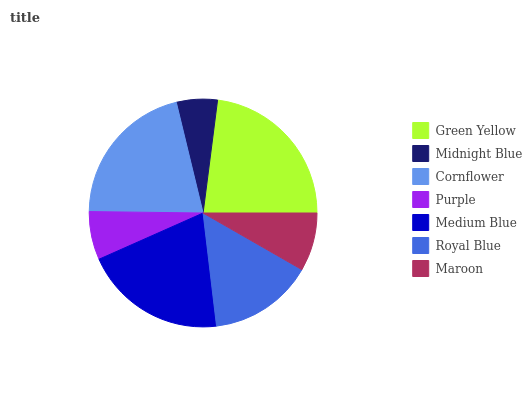Is Midnight Blue the minimum?
Answer yes or no. Yes. Is Green Yellow the maximum?
Answer yes or no. Yes. Is Cornflower the minimum?
Answer yes or no. No. Is Cornflower the maximum?
Answer yes or no. No. Is Cornflower greater than Midnight Blue?
Answer yes or no. Yes. Is Midnight Blue less than Cornflower?
Answer yes or no. Yes. Is Midnight Blue greater than Cornflower?
Answer yes or no. No. Is Cornflower less than Midnight Blue?
Answer yes or no. No. Is Royal Blue the high median?
Answer yes or no. Yes. Is Royal Blue the low median?
Answer yes or no. Yes. Is Green Yellow the high median?
Answer yes or no. No. Is Medium Blue the low median?
Answer yes or no. No. 